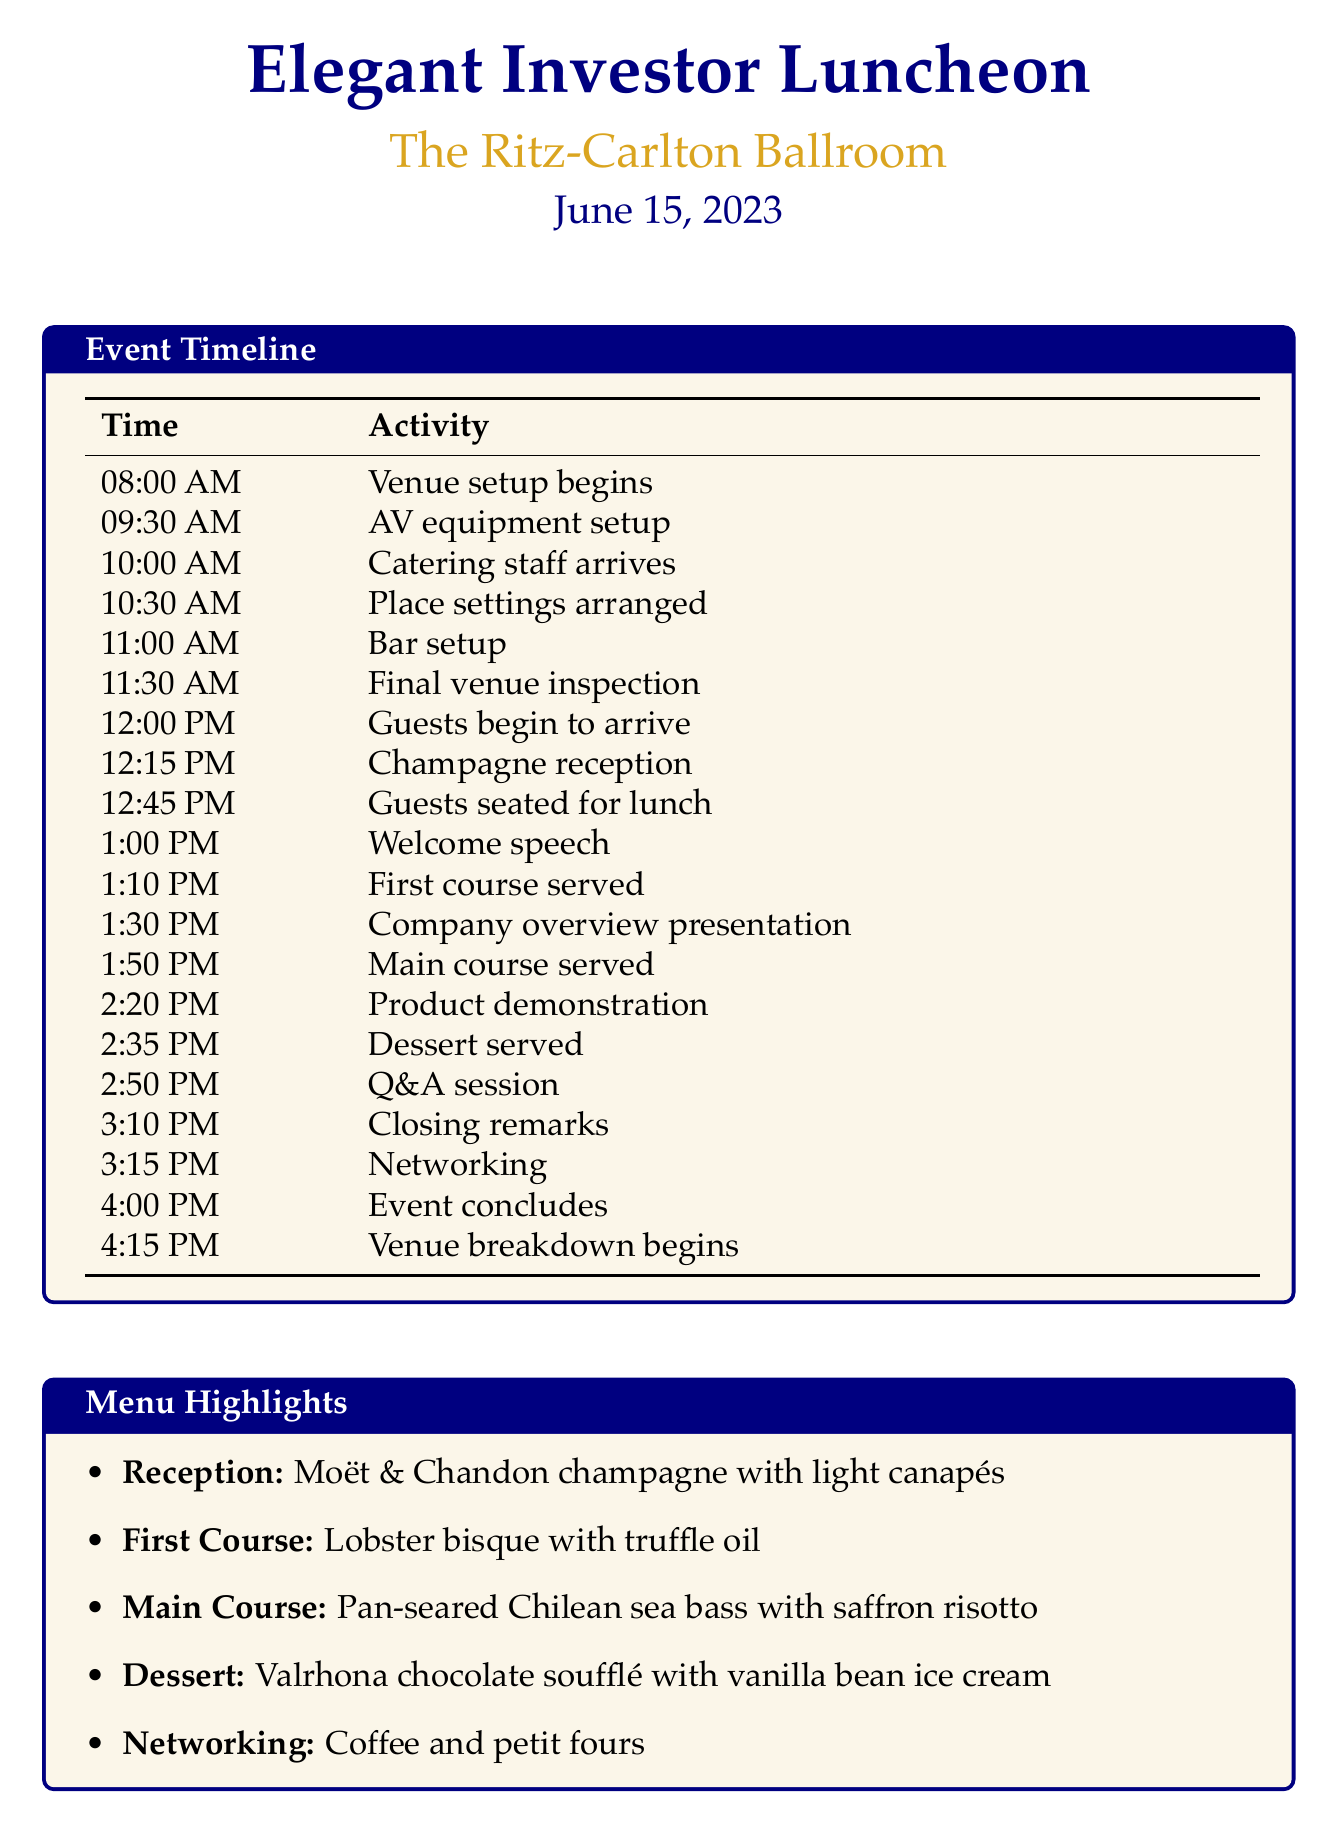What is the event name? The event name is listed at the top of the document, referring to the luncheon being organized.
Answer: Elegant Investor Luncheon What is the venue for the luncheon? The venue for the luncheon is mentioned in the document to indicate where the event is being held.
Answer: The Ritz-Carlton Ballroom What time does the venue setup begin? The document outlines the timeline, and the specific start time for venue setup is indicated.
Answer: 08:00 AM How long is the company overview presentation? The length of the company overview presentation is specified in the key presentations section of the document.
Answer: 20 minutes What is served during the networking session? The document details what refreshments are provided during the networking portion of the event.
Answer: Coffee and petit fours What is the first course served? The document lists the meal courses, identifying the specific dish for the first course.
Answer: Lobster bisque with truffle oil What time does the event conclude? The timeline specifies the exact time when the event is scheduled to end.
Answer: 4:00 PM How many minutes long is the Q&A session? The key presentations section of the document indicates the duration allocated for the Q&A session.
Answer: 20 minutes What activity follows the main course? The timeline outlines the sequence of activities, specifically what comes after the main course is served.
Answer: Product demonstration 